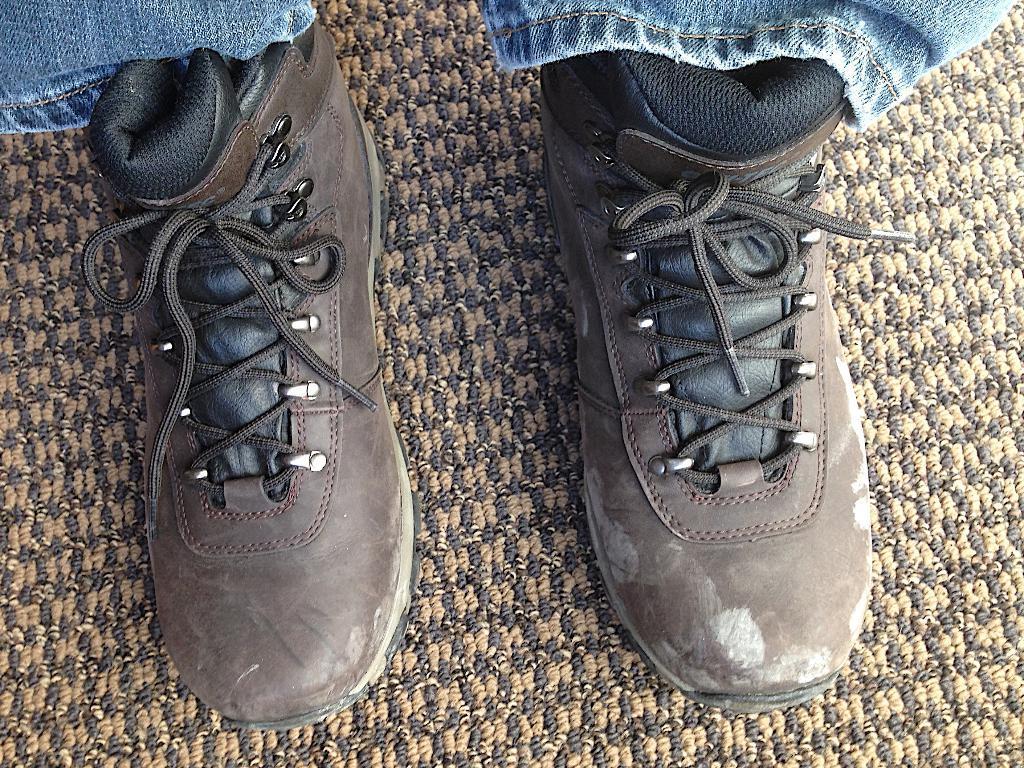Describe this image in one or two sentences. In this image we can see that there are shoes on the mat. 